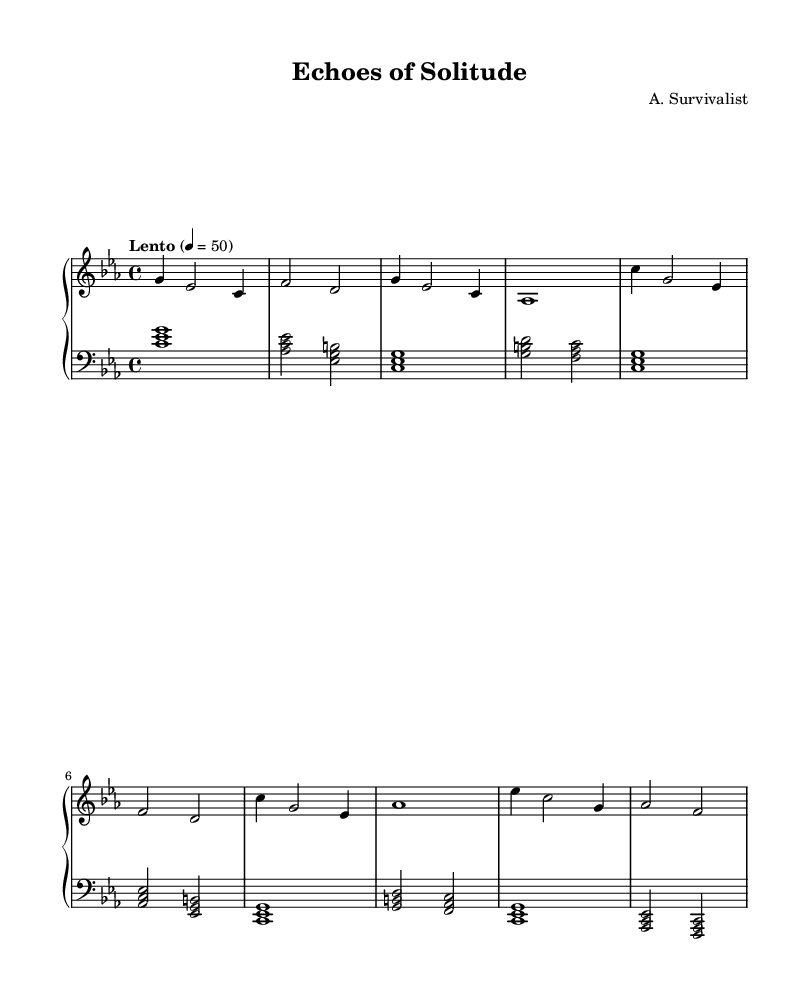What is the key signature of this music? The key signature is C minor, which has three flats (B♭, E♭, and A♭). This can be determined by the indicator at the beginning of the staff, which shows the relative positions of the flats.
Answer: C minor What is the time signature of this piece? The time signature is indicated at the beginning of the staff, where it shows 4/4, meaning there are four beats in each measure and the quarter note gets one beat.
Answer: 4/4 What is the tempo marking for this composition? The tempo marking is found at the start of the sheet music; it states "Lento," which indicates a slow tempo, typically around 50 beats per minute.
Answer: Lento How many measures are present in the right-hand part? To find the number of measures, we can count the vertical lines separating the groups of notes in the right-hand part. There are a total of 8 measures.
Answer: 8 Which theme appears first in this piece? The first theme present in the music is labeled Theme A. It can be found in the right hand after the introductory section, indicated by the consistent pattern of notes that defines it.
Answer: Theme A What type of harmony is primarily used in the left hand? The left hand predominantly uses block chords, which are played as clusters of notes struck together, creating a rich harmonic accompaniment full of depth.
Answer: Block chords What is the overall mood suggested by this piece? The structure and tempo, along with the gentle harmonies and melodic lines, suggest an introspective and serene mood, often found in Romantic ambient pieces.
Answer: Serene 